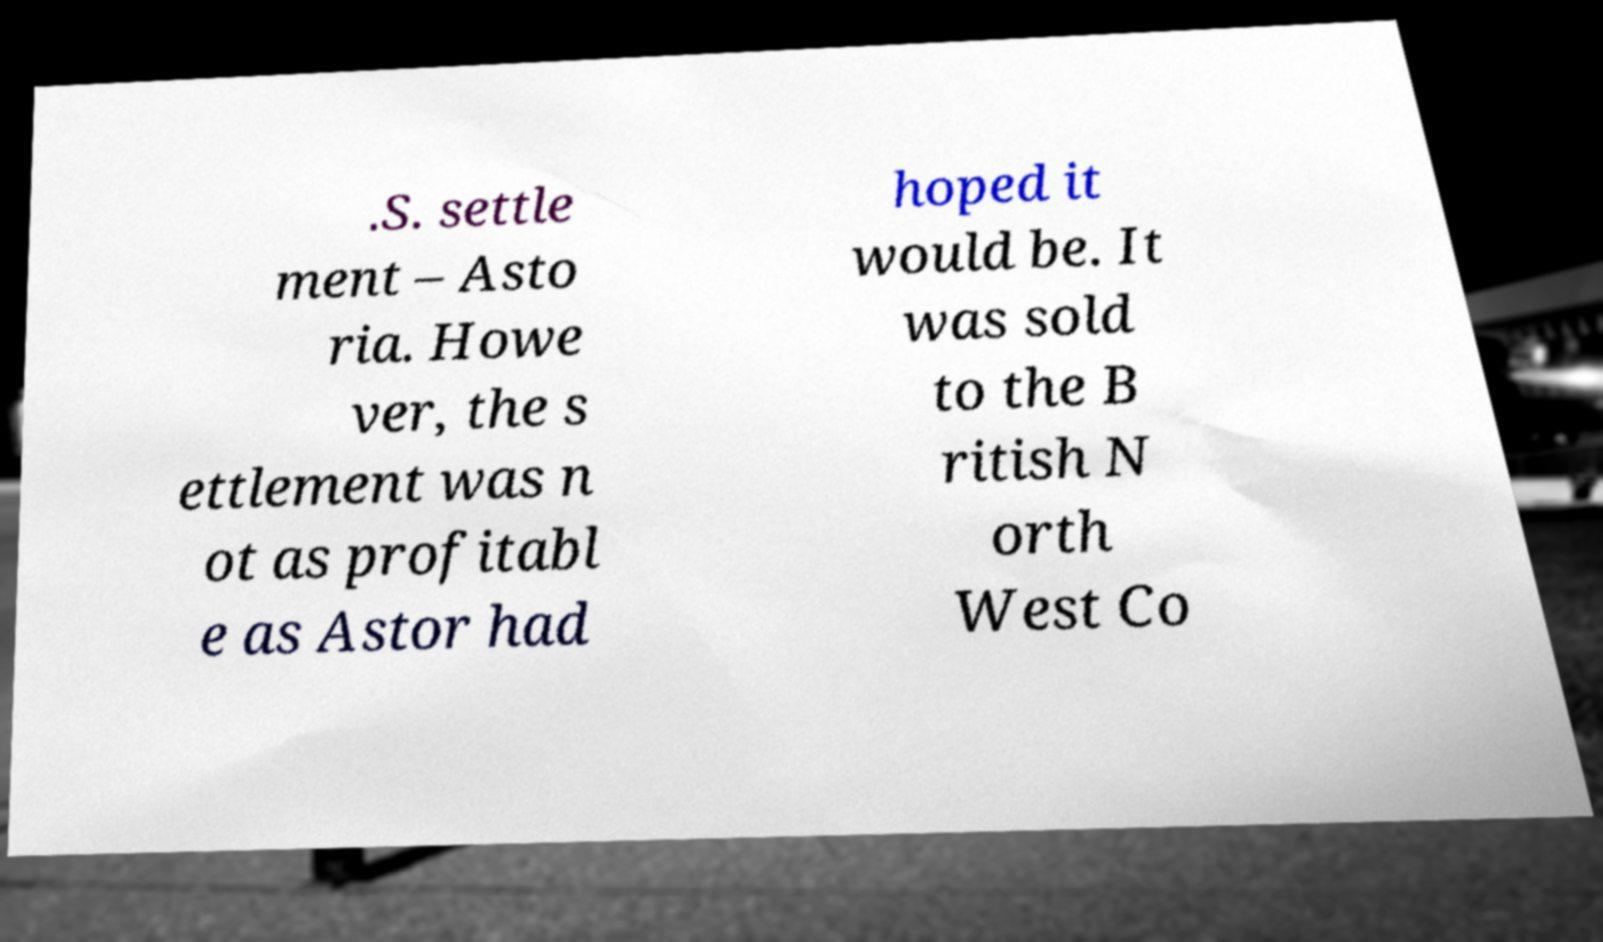I need the written content from this picture converted into text. Can you do that? .S. settle ment – Asto ria. Howe ver, the s ettlement was n ot as profitabl e as Astor had hoped it would be. It was sold to the B ritish N orth West Co 